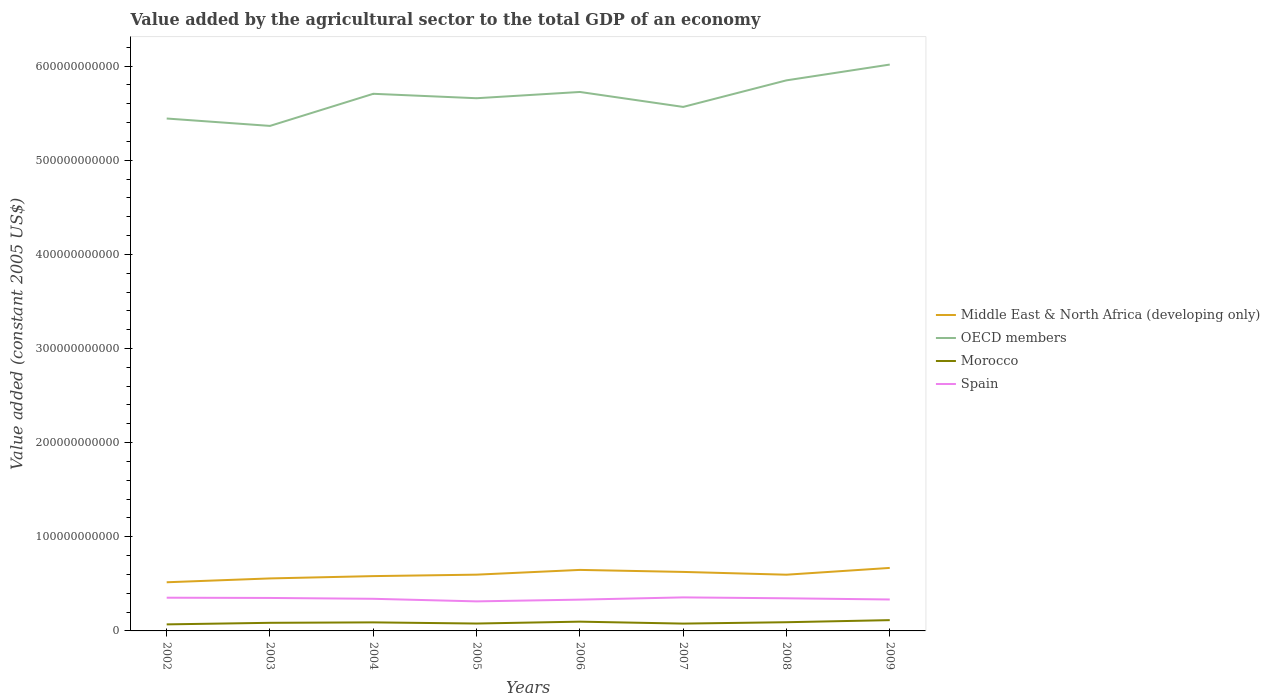How many different coloured lines are there?
Offer a very short reply. 4. Does the line corresponding to Middle East & North Africa (developing only) intersect with the line corresponding to Spain?
Provide a short and direct response. No. Is the number of lines equal to the number of legend labels?
Provide a succinct answer. Yes. Across all years, what is the maximum value added by the agricultural sector in Middle East & North Africa (developing only)?
Your answer should be very brief. 5.17e+1. In which year was the value added by the agricultural sector in Morocco maximum?
Give a very brief answer. 2002. What is the total value added by the agricultural sector in Middle East & North Africa (developing only) in the graph?
Your response must be concise. -1.55e+09. What is the difference between the highest and the second highest value added by the agricultural sector in OECD members?
Your answer should be very brief. 6.52e+1. What is the difference between the highest and the lowest value added by the agricultural sector in Middle East & North Africa (developing only)?
Offer a terse response. 3. Is the value added by the agricultural sector in Spain strictly greater than the value added by the agricultural sector in OECD members over the years?
Your response must be concise. Yes. What is the difference between two consecutive major ticks on the Y-axis?
Keep it short and to the point. 1.00e+11. Does the graph contain grids?
Ensure brevity in your answer.  No. What is the title of the graph?
Make the answer very short. Value added by the agricultural sector to the total GDP of an economy. What is the label or title of the Y-axis?
Provide a short and direct response. Value added (constant 2005 US$). What is the Value added (constant 2005 US$) of Middle East & North Africa (developing only) in 2002?
Keep it short and to the point. 5.17e+1. What is the Value added (constant 2005 US$) of OECD members in 2002?
Provide a short and direct response. 5.44e+11. What is the Value added (constant 2005 US$) of Morocco in 2002?
Your response must be concise. 6.95e+09. What is the Value added (constant 2005 US$) of Spain in 2002?
Provide a succinct answer. 3.53e+1. What is the Value added (constant 2005 US$) in Middle East & North Africa (developing only) in 2003?
Offer a very short reply. 5.58e+1. What is the Value added (constant 2005 US$) in OECD members in 2003?
Give a very brief answer. 5.36e+11. What is the Value added (constant 2005 US$) in Morocco in 2003?
Your answer should be compact. 8.62e+09. What is the Value added (constant 2005 US$) of Spain in 2003?
Offer a very short reply. 3.50e+1. What is the Value added (constant 2005 US$) of Middle East & North Africa (developing only) in 2004?
Your answer should be very brief. 5.82e+1. What is the Value added (constant 2005 US$) of OECD members in 2004?
Provide a succinct answer. 5.71e+11. What is the Value added (constant 2005 US$) in Morocco in 2004?
Make the answer very short. 9.07e+09. What is the Value added (constant 2005 US$) in Spain in 2004?
Offer a very short reply. 3.41e+1. What is the Value added (constant 2005 US$) of Middle East & North Africa (developing only) in 2005?
Ensure brevity in your answer.  5.98e+1. What is the Value added (constant 2005 US$) in OECD members in 2005?
Give a very brief answer. 5.66e+11. What is the Value added (constant 2005 US$) in Morocco in 2005?
Your answer should be very brief. 7.85e+09. What is the Value added (constant 2005 US$) of Spain in 2005?
Make the answer very short. 3.14e+1. What is the Value added (constant 2005 US$) of Middle East & North Africa (developing only) in 2006?
Provide a short and direct response. 6.48e+1. What is the Value added (constant 2005 US$) in OECD members in 2006?
Make the answer very short. 5.72e+11. What is the Value added (constant 2005 US$) in Morocco in 2006?
Provide a short and direct response. 9.83e+09. What is the Value added (constant 2005 US$) of Spain in 2006?
Keep it short and to the point. 3.32e+1. What is the Value added (constant 2005 US$) of Middle East & North Africa (developing only) in 2007?
Provide a short and direct response. 6.27e+1. What is the Value added (constant 2005 US$) in OECD members in 2007?
Your response must be concise. 5.57e+11. What is the Value added (constant 2005 US$) in Morocco in 2007?
Your response must be concise. 7.79e+09. What is the Value added (constant 2005 US$) of Spain in 2007?
Offer a terse response. 3.56e+1. What is the Value added (constant 2005 US$) of Middle East & North Africa (developing only) in 2008?
Provide a succinct answer. 5.97e+1. What is the Value added (constant 2005 US$) in OECD members in 2008?
Provide a succinct answer. 5.85e+11. What is the Value added (constant 2005 US$) of Morocco in 2008?
Your response must be concise. 9.24e+09. What is the Value added (constant 2005 US$) in Spain in 2008?
Offer a terse response. 3.47e+1. What is the Value added (constant 2005 US$) of Middle East & North Africa (developing only) in 2009?
Make the answer very short. 6.69e+1. What is the Value added (constant 2005 US$) of OECD members in 2009?
Offer a terse response. 6.02e+11. What is the Value added (constant 2005 US$) in Morocco in 2009?
Provide a succinct answer. 1.15e+1. What is the Value added (constant 2005 US$) of Spain in 2009?
Your answer should be very brief. 3.34e+1. Across all years, what is the maximum Value added (constant 2005 US$) in Middle East & North Africa (developing only)?
Offer a terse response. 6.69e+1. Across all years, what is the maximum Value added (constant 2005 US$) of OECD members?
Keep it short and to the point. 6.02e+11. Across all years, what is the maximum Value added (constant 2005 US$) of Morocco?
Offer a very short reply. 1.15e+1. Across all years, what is the maximum Value added (constant 2005 US$) in Spain?
Provide a short and direct response. 3.56e+1. Across all years, what is the minimum Value added (constant 2005 US$) in Middle East & North Africa (developing only)?
Give a very brief answer. 5.17e+1. Across all years, what is the minimum Value added (constant 2005 US$) in OECD members?
Make the answer very short. 5.36e+11. Across all years, what is the minimum Value added (constant 2005 US$) in Morocco?
Offer a very short reply. 6.95e+09. Across all years, what is the minimum Value added (constant 2005 US$) in Spain?
Your answer should be very brief. 3.14e+1. What is the total Value added (constant 2005 US$) in Middle East & North Africa (developing only) in the graph?
Keep it short and to the point. 4.80e+11. What is the total Value added (constant 2005 US$) in OECD members in the graph?
Offer a terse response. 4.53e+12. What is the total Value added (constant 2005 US$) of Morocco in the graph?
Your answer should be compact. 7.08e+1. What is the total Value added (constant 2005 US$) of Spain in the graph?
Give a very brief answer. 2.73e+11. What is the difference between the Value added (constant 2005 US$) in Middle East & North Africa (developing only) in 2002 and that in 2003?
Give a very brief answer. -4.07e+09. What is the difference between the Value added (constant 2005 US$) in OECD members in 2002 and that in 2003?
Ensure brevity in your answer.  7.85e+09. What is the difference between the Value added (constant 2005 US$) of Morocco in 2002 and that in 2003?
Offer a very short reply. -1.67e+09. What is the difference between the Value added (constant 2005 US$) of Spain in 2002 and that in 2003?
Offer a very short reply. 2.76e+08. What is the difference between the Value added (constant 2005 US$) of Middle East & North Africa (developing only) in 2002 and that in 2004?
Keep it short and to the point. -6.53e+09. What is the difference between the Value added (constant 2005 US$) of OECD members in 2002 and that in 2004?
Ensure brevity in your answer.  -2.63e+1. What is the difference between the Value added (constant 2005 US$) in Morocco in 2002 and that in 2004?
Your response must be concise. -2.12e+09. What is the difference between the Value added (constant 2005 US$) of Spain in 2002 and that in 2004?
Make the answer very short. 1.16e+09. What is the difference between the Value added (constant 2005 US$) of Middle East & North Africa (developing only) in 2002 and that in 2005?
Ensure brevity in your answer.  -8.07e+09. What is the difference between the Value added (constant 2005 US$) in OECD members in 2002 and that in 2005?
Ensure brevity in your answer.  -2.15e+1. What is the difference between the Value added (constant 2005 US$) of Morocco in 2002 and that in 2005?
Your response must be concise. -9.00e+08. What is the difference between the Value added (constant 2005 US$) of Spain in 2002 and that in 2005?
Ensure brevity in your answer.  3.90e+09. What is the difference between the Value added (constant 2005 US$) in Middle East & North Africa (developing only) in 2002 and that in 2006?
Offer a terse response. -1.31e+1. What is the difference between the Value added (constant 2005 US$) of OECD members in 2002 and that in 2006?
Offer a very short reply. -2.82e+1. What is the difference between the Value added (constant 2005 US$) of Morocco in 2002 and that in 2006?
Your response must be concise. -2.89e+09. What is the difference between the Value added (constant 2005 US$) in Spain in 2002 and that in 2006?
Make the answer very short. 2.04e+09. What is the difference between the Value added (constant 2005 US$) of Middle East & North Africa (developing only) in 2002 and that in 2007?
Keep it short and to the point. -1.10e+1. What is the difference between the Value added (constant 2005 US$) in OECD members in 2002 and that in 2007?
Your answer should be very brief. -1.23e+1. What is the difference between the Value added (constant 2005 US$) of Morocco in 2002 and that in 2007?
Offer a terse response. -8.42e+08. What is the difference between the Value added (constant 2005 US$) in Spain in 2002 and that in 2007?
Your answer should be very brief. -3.35e+08. What is the difference between the Value added (constant 2005 US$) of Middle East & North Africa (developing only) in 2002 and that in 2008?
Your answer should be compact. -8.03e+09. What is the difference between the Value added (constant 2005 US$) in OECD members in 2002 and that in 2008?
Keep it short and to the point. -4.05e+1. What is the difference between the Value added (constant 2005 US$) of Morocco in 2002 and that in 2008?
Keep it short and to the point. -2.29e+09. What is the difference between the Value added (constant 2005 US$) in Spain in 2002 and that in 2008?
Make the answer very short. 6.31e+08. What is the difference between the Value added (constant 2005 US$) in Middle East & North Africa (developing only) in 2002 and that in 2009?
Provide a succinct answer. -1.52e+1. What is the difference between the Value added (constant 2005 US$) in OECD members in 2002 and that in 2009?
Your response must be concise. -5.73e+1. What is the difference between the Value added (constant 2005 US$) of Morocco in 2002 and that in 2009?
Offer a terse response. -4.51e+09. What is the difference between the Value added (constant 2005 US$) of Spain in 2002 and that in 2009?
Ensure brevity in your answer.  1.89e+09. What is the difference between the Value added (constant 2005 US$) in Middle East & North Africa (developing only) in 2003 and that in 2004?
Offer a very short reply. -2.45e+09. What is the difference between the Value added (constant 2005 US$) in OECD members in 2003 and that in 2004?
Keep it short and to the point. -3.41e+1. What is the difference between the Value added (constant 2005 US$) of Morocco in 2003 and that in 2004?
Your answer should be very brief. -4.49e+08. What is the difference between the Value added (constant 2005 US$) of Spain in 2003 and that in 2004?
Keep it short and to the point. 8.86e+08. What is the difference between the Value added (constant 2005 US$) in Middle East & North Africa (developing only) in 2003 and that in 2005?
Ensure brevity in your answer.  -4.00e+09. What is the difference between the Value added (constant 2005 US$) of OECD members in 2003 and that in 2005?
Ensure brevity in your answer.  -2.94e+1. What is the difference between the Value added (constant 2005 US$) of Morocco in 2003 and that in 2005?
Provide a short and direct response. 7.74e+08. What is the difference between the Value added (constant 2005 US$) in Spain in 2003 and that in 2005?
Your answer should be compact. 3.63e+09. What is the difference between the Value added (constant 2005 US$) of Middle East & North Africa (developing only) in 2003 and that in 2006?
Provide a succinct answer. -9.05e+09. What is the difference between the Value added (constant 2005 US$) in OECD members in 2003 and that in 2006?
Keep it short and to the point. -3.61e+1. What is the difference between the Value added (constant 2005 US$) of Morocco in 2003 and that in 2006?
Provide a short and direct response. -1.21e+09. What is the difference between the Value added (constant 2005 US$) in Spain in 2003 and that in 2006?
Provide a succinct answer. 1.77e+09. What is the difference between the Value added (constant 2005 US$) in Middle East & North Africa (developing only) in 2003 and that in 2007?
Your answer should be compact. -6.91e+09. What is the difference between the Value added (constant 2005 US$) in OECD members in 2003 and that in 2007?
Your answer should be compact. -2.02e+1. What is the difference between the Value added (constant 2005 US$) in Morocco in 2003 and that in 2007?
Provide a succinct answer. 8.32e+08. What is the difference between the Value added (constant 2005 US$) in Spain in 2003 and that in 2007?
Your response must be concise. -6.11e+08. What is the difference between the Value added (constant 2005 US$) of Middle East & North Africa (developing only) in 2003 and that in 2008?
Provide a short and direct response. -3.95e+09. What is the difference between the Value added (constant 2005 US$) in OECD members in 2003 and that in 2008?
Provide a succinct answer. -4.84e+1. What is the difference between the Value added (constant 2005 US$) of Morocco in 2003 and that in 2008?
Make the answer very short. -6.19e+08. What is the difference between the Value added (constant 2005 US$) of Spain in 2003 and that in 2008?
Provide a succinct answer. 3.55e+08. What is the difference between the Value added (constant 2005 US$) in Middle East & North Africa (developing only) in 2003 and that in 2009?
Provide a short and direct response. -1.12e+1. What is the difference between the Value added (constant 2005 US$) in OECD members in 2003 and that in 2009?
Offer a terse response. -6.52e+1. What is the difference between the Value added (constant 2005 US$) in Morocco in 2003 and that in 2009?
Make the answer very short. -2.83e+09. What is the difference between the Value added (constant 2005 US$) of Spain in 2003 and that in 2009?
Provide a short and direct response. 1.61e+09. What is the difference between the Value added (constant 2005 US$) in Middle East & North Africa (developing only) in 2004 and that in 2005?
Your answer should be compact. -1.55e+09. What is the difference between the Value added (constant 2005 US$) in OECD members in 2004 and that in 2005?
Provide a short and direct response. 4.70e+09. What is the difference between the Value added (constant 2005 US$) in Morocco in 2004 and that in 2005?
Give a very brief answer. 1.22e+09. What is the difference between the Value added (constant 2005 US$) of Spain in 2004 and that in 2005?
Give a very brief answer. 2.74e+09. What is the difference between the Value added (constant 2005 US$) in Middle East & North Africa (developing only) in 2004 and that in 2006?
Your answer should be very brief. -6.59e+09. What is the difference between the Value added (constant 2005 US$) of OECD members in 2004 and that in 2006?
Offer a very short reply. -1.95e+09. What is the difference between the Value added (constant 2005 US$) in Morocco in 2004 and that in 2006?
Make the answer very short. -7.64e+08. What is the difference between the Value added (constant 2005 US$) of Spain in 2004 and that in 2006?
Keep it short and to the point. 8.82e+08. What is the difference between the Value added (constant 2005 US$) of Middle East & North Africa (developing only) in 2004 and that in 2007?
Give a very brief answer. -4.46e+09. What is the difference between the Value added (constant 2005 US$) in OECD members in 2004 and that in 2007?
Provide a succinct answer. 1.39e+1. What is the difference between the Value added (constant 2005 US$) of Morocco in 2004 and that in 2007?
Your answer should be very brief. 1.28e+09. What is the difference between the Value added (constant 2005 US$) in Spain in 2004 and that in 2007?
Provide a short and direct response. -1.50e+09. What is the difference between the Value added (constant 2005 US$) in Middle East & North Africa (developing only) in 2004 and that in 2008?
Ensure brevity in your answer.  -1.50e+09. What is the difference between the Value added (constant 2005 US$) of OECD members in 2004 and that in 2008?
Give a very brief answer. -1.43e+1. What is the difference between the Value added (constant 2005 US$) of Morocco in 2004 and that in 2008?
Offer a terse response. -1.69e+08. What is the difference between the Value added (constant 2005 US$) of Spain in 2004 and that in 2008?
Your answer should be compact. -5.31e+08. What is the difference between the Value added (constant 2005 US$) in Middle East & North Africa (developing only) in 2004 and that in 2009?
Provide a succinct answer. -8.71e+09. What is the difference between the Value added (constant 2005 US$) in OECD members in 2004 and that in 2009?
Your answer should be very brief. -3.11e+1. What is the difference between the Value added (constant 2005 US$) of Morocco in 2004 and that in 2009?
Keep it short and to the point. -2.38e+09. What is the difference between the Value added (constant 2005 US$) of Spain in 2004 and that in 2009?
Your answer should be very brief. 7.28e+08. What is the difference between the Value added (constant 2005 US$) in Middle East & North Africa (developing only) in 2005 and that in 2006?
Provide a short and direct response. -5.05e+09. What is the difference between the Value added (constant 2005 US$) in OECD members in 2005 and that in 2006?
Offer a very short reply. -6.65e+09. What is the difference between the Value added (constant 2005 US$) of Morocco in 2005 and that in 2006?
Ensure brevity in your answer.  -1.99e+09. What is the difference between the Value added (constant 2005 US$) in Spain in 2005 and that in 2006?
Keep it short and to the point. -1.86e+09. What is the difference between the Value added (constant 2005 US$) of Middle East & North Africa (developing only) in 2005 and that in 2007?
Ensure brevity in your answer.  -2.91e+09. What is the difference between the Value added (constant 2005 US$) of OECD members in 2005 and that in 2007?
Your response must be concise. 9.23e+09. What is the difference between the Value added (constant 2005 US$) of Morocco in 2005 and that in 2007?
Ensure brevity in your answer.  5.80e+07. What is the difference between the Value added (constant 2005 US$) in Spain in 2005 and that in 2007?
Provide a short and direct response. -4.24e+09. What is the difference between the Value added (constant 2005 US$) of Middle East & North Africa (developing only) in 2005 and that in 2008?
Offer a terse response. 4.66e+07. What is the difference between the Value added (constant 2005 US$) in OECD members in 2005 and that in 2008?
Your answer should be compact. -1.90e+1. What is the difference between the Value added (constant 2005 US$) in Morocco in 2005 and that in 2008?
Ensure brevity in your answer.  -1.39e+09. What is the difference between the Value added (constant 2005 US$) in Spain in 2005 and that in 2008?
Provide a short and direct response. -3.27e+09. What is the difference between the Value added (constant 2005 US$) in Middle East & North Africa (developing only) in 2005 and that in 2009?
Give a very brief answer. -7.17e+09. What is the difference between the Value added (constant 2005 US$) in OECD members in 2005 and that in 2009?
Your response must be concise. -3.58e+1. What is the difference between the Value added (constant 2005 US$) in Morocco in 2005 and that in 2009?
Offer a very short reply. -3.60e+09. What is the difference between the Value added (constant 2005 US$) of Spain in 2005 and that in 2009?
Offer a very short reply. -2.01e+09. What is the difference between the Value added (constant 2005 US$) of Middle East & North Africa (developing only) in 2006 and that in 2007?
Your answer should be very brief. 2.13e+09. What is the difference between the Value added (constant 2005 US$) of OECD members in 2006 and that in 2007?
Offer a terse response. 1.59e+1. What is the difference between the Value added (constant 2005 US$) in Morocco in 2006 and that in 2007?
Provide a short and direct response. 2.04e+09. What is the difference between the Value added (constant 2005 US$) of Spain in 2006 and that in 2007?
Your response must be concise. -2.38e+09. What is the difference between the Value added (constant 2005 US$) of Middle East & North Africa (developing only) in 2006 and that in 2008?
Your answer should be compact. 5.09e+09. What is the difference between the Value added (constant 2005 US$) of OECD members in 2006 and that in 2008?
Ensure brevity in your answer.  -1.23e+1. What is the difference between the Value added (constant 2005 US$) of Morocco in 2006 and that in 2008?
Ensure brevity in your answer.  5.94e+08. What is the difference between the Value added (constant 2005 US$) of Spain in 2006 and that in 2008?
Ensure brevity in your answer.  -1.41e+09. What is the difference between the Value added (constant 2005 US$) in Middle East & North Africa (developing only) in 2006 and that in 2009?
Your answer should be very brief. -2.12e+09. What is the difference between the Value added (constant 2005 US$) of OECD members in 2006 and that in 2009?
Keep it short and to the point. -2.91e+1. What is the difference between the Value added (constant 2005 US$) in Morocco in 2006 and that in 2009?
Ensure brevity in your answer.  -1.62e+09. What is the difference between the Value added (constant 2005 US$) of Spain in 2006 and that in 2009?
Your response must be concise. -1.54e+08. What is the difference between the Value added (constant 2005 US$) in Middle East & North Africa (developing only) in 2007 and that in 2008?
Offer a terse response. 2.96e+09. What is the difference between the Value added (constant 2005 US$) in OECD members in 2007 and that in 2008?
Your answer should be very brief. -2.82e+1. What is the difference between the Value added (constant 2005 US$) of Morocco in 2007 and that in 2008?
Give a very brief answer. -1.45e+09. What is the difference between the Value added (constant 2005 US$) in Spain in 2007 and that in 2008?
Give a very brief answer. 9.66e+08. What is the difference between the Value added (constant 2005 US$) of Middle East & North Africa (developing only) in 2007 and that in 2009?
Your answer should be very brief. -4.25e+09. What is the difference between the Value added (constant 2005 US$) of OECD members in 2007 and that in 2009?
Your answer should be compact. -4.50e+1. What is the difference between the Value added (constant 2005 US$) in Morocco in 2007 and that in 2009?
Provide a short and direct response. -3.66e+09. What is the difference between the Value added (constant 2005 US$) of Spain in 2007 and that in 2009?
Your answer should be very brief. 2.22e+09. What is the difference between the Value added (constant 2005 US$) of Middle East & North Africa (developing only) in 2008 and that in 2009?
Provide a succinct answer. -7.21e+09. What is the difference between the Value added (constant 2005 US$) in OECD members in 2008 and that in 2009?
Provide a succinct answer. -1.68e+1. What is the difference between the Value added (constant 2005 US$) of Morocco in 2008 and that in 2009?
Your answer should be very brief. -2.21e+09. What is the difference between the Value added (constant 2005 US$) of Spain in 2008 and that in 2009?
Make the answer very short. 1.26e+09. What is the difference between the Value added (constant 2005 US$) of Middle East & North Africa (developing only) in 2002 and the Value added (constant 2005 US$) of OECD members in 2003?
Offer a terse response. -4.85e+11. What is the difference between the Value added (constant 2005 US$) in Middle East & North Africa (developing only) in 2002 and the Value added (constant 2005 US$) in Morocco in 2003?
Your response must be concise. 4.31e+1. What is the difference between the Value added (constant 2005 US$) of Middle East & North Africa (developing only) in 2002 and the Value added (constant 2005 US$) of Spain in 2003?
Give a very brief answer. 1.67e+1. What is the difference between the Value added (constant 2005 US$) of OECD members in 2002 and the Value added (constant 2005 US$) of Morocco in 2003?
Keep it short and to the point. 5.36e+11. What is the difference between the Value added (constant 2005 US$) in OECD members in 2002 and the Value added (constant 2005 US$) in Spain in 2003?
Offer a terse response. 5.09e+11. What is the difference between the Value added (constant 2005 US$) in Morocco in 2002 and the Value added (constant 2005 US$) in Spain in 2003?
Provide a succinct answer. -2.81e+1. What is the difference between the Value added (constant 2005 US$) of Middle East & North Africa (developing only) in 2002 and the Value added (constant 2005 US$) of OECD members in 2004?
Offer a very short reply. -5.19e+11. What is the difference between the Value added (constant 2005 US$) in Middle East & North Africa (developing only) in 2002 and the Value added (constant 2005 US$) in Morocco in 2004?
Offer a very short reply. 4.26e+1. What is the difference between the Value added (constant 2005 US$) in Middle East & North Africa (developing only) in 2002 and the Value added (constant 2005 US$) in Spain in 2004?
Offer a very short reply. 1.76e+1. What is the difference between the Value added (constant 2005 US$) in OECD members in 2002 and the Value added (constant 2005 US$) in Morocco in 2004?
Ensure brevity in your answer.  5.35e+11. What is the difference between the Value added (constant 2005 US$) in OECD members in 2002 and the Value added (constant 2005 US$) in Spain in 2004?
Provide a succinct answer. 5.10e+11. What is the difference between the Value added (constant 2005 US$) of Morocco in 2002 and the Value added (constant 2005 US$) of Spain in 2004?
Your response must be concise. -2.72e+1. What is the difference between the Value added (constant 2005 US$) in Middle East & North Africa (developing only) in 2002 and the Value added (constant 2005 US$) in OECD members in 2005?
Give a very brief answer. -5.14e+11. What is the difference between the Value added (constant 2005 US$) of Middle East & North Africa (developing only) in 2002 and the Value added (constant 2005 US$) of Morocco in 2005?
Offer a terse response. 4.38e+1. What is the difference between the Value added (constant 2005 US$) in Middle East & North Africa (developing only) in 2002 and the Value added (constant 2005 US$) in Spain in 2005?
Make the answer very short. 2.03e+1. What is the difference between the Value added (constant 2005 US$) in OECD members in 2002 and the Value added (constant 2005 US$) in Morocco in 2005?
Your response must be concise. 5.36e+11. What is the difference between the Value added (constant 2005 US$) of OECD members in 2002 and the Value added (constant 2005 US$) of Spain in 2005?
Your answer should be compact. 5.13e+11. What is the difference between the Value added (constant 2005 US$) in Morocco in 2002 and the Value added (constant 2005 US$) in Spain in 2005?
Your answer should be compact. -2.44e+1. What is the difference between the Value added (constant 2005 US$) in Middle East & North Africa (developing only) in 2002 and the Value added (constant 2005 US$) in OECD members in 2006?
Keep it short and to the point. -5.21e+11. What is the difference between the Value added (constant 2005 US$) of Middle East & North Africa (developing only) in 2002 and the Value added (constant 2005 US$) of Morocco in 2006?
Offer a terse response. 4.19e+1. What is the difference between the Value added (constant 2005 US$) of Middle East & North Africa (developing only) in 2002 and the Value added (constant 2005 US$) of Spain in 2006?
Provide a succinct answer. 1.84e+1. What is the difference between the Value added (constant 2005 US$) in OECD members in 2002 and the Value added (constant 2005 US$) in Morocco in 2006?
Offer a terse response. 5.34e+11. What is the difference between the Value added (constant 2005 US$) of OECD members in 2002 and the Value added (constant 2005 US$) of Spain in 2006?
Your response must be concise. 5.11e+11. What is the difference between the Value added (constant 2005 US$) in Morocco in 2002 and the Value added (constant 2005 US$) in Spain in 2006?
Your response must be concise. -2.63e+1. What is the difference between the Value added (constant 2005 US$) in Middle East & North Africa (developing only) in 2002 and the Value added (constant 2005 US$) in OECD members in 2007?
Offer a terse response. -5.05e+11. What is the difference between the Value added (constant 2005 US$) in Middle East & North Africa (developing only) in 2002 and the Value added (constant 2005 US$) in Morocco in 2007?
Your answer should be very brief. 4.39e+1. What is the difference between the Value added (constant 2005 US$) of Middle East & North Africa (developing only) in 2002 and the Value added (constant 2005 US$) of Spain in 2007?
Offer a very short reply. 1.61e+1. What is the difference between the Value added (constant 2005 US$) in OECD members in 2002 and the Value added (constant 2005 US$) in Morocco in 2007?
Provide a short and direct response. 5.37e+11. What is the difference between the Value added (constant 2005 US$) in OECD members in 2002 and the Value added (constant 2005 US$) in Spain in 2007?
Provide a succinct answer. 5.09e+11. What is the difference between the Value added (constant 2005 US$) in Morocco in 2002 and the Value added (constant 2005 US$) in Spain in 2007?
Provide a short and direct response. -2.87e+1. What is the difference between the Value added (constant 2005 US$) in Middle East & North Africa (developing only) in 2002 and the Value added (constant 2005 US$) in OECD members in 2008?
Offer a terse response. -5.33e+11. What is the difference between the Value added (constant 2005 US$) in Middle East & North Africa (developing only) in 2002 and the Value added (constant 2005 US$) in Morocco in 2008?
Provide a short and direct response. 4.24e+1. What is the difference between the Value added (constant 2005 US$) in Middle East & North Africa (developing only) in 2002 and the Value added (constant 2005 US$) in Spain in 2008?
Keep it short and to the point. 1.70e+1. What is the difference between the Value added (constant 2005 US$) in OECD members in 2002 and the Value added (constant 2005 US$) in Morocco in 2008?
Offer a very short reply. 5.35e+11. What is the difference between the Value added (constant 2005 US$) in OECD members in 2002 and the Value added (constant 2005 US$) in Spain in 2008?
Provide a succinct answer. 5.10e+11. What is the difference between the Value added (constant 2005 US$) of Morocco in 2002 and the Value added (constant 2005 US$) of Spain in 2008?
Make the answer very short. -2.77e+1. What is the difference between the Value added (constant 2005 US$) of Middle East & North Africa (developing only) in 2002 and the Value added (constant 2005 US$) of OECD members in 2009?
Keep it short and to the point. -5.50e+11. What is the difference between the Value added (constant 2005 US$) in Middle East & North Africa (developing only) in 2002 and the Value added (constant 2005 US$) in Morocco in 2009?
Your answer should be very brief. 4.02e+1. What is the difference between the Value added (constant 2005 US$) of Middle East & North Africa (developing only) in 2002 and the Value added (constant 2005 US$) of Spain in 2009?
Make the answer very short. 1.83e+1. What is the difference between the Value added (constant 2005 US$) of OECD members in 2002 and the Value added (constant 2005 US$) of Morocco in 2009?
Give a very brief answer. 5.33e+11. What is the difference between the Value added (constant 2005 US$) of OECD members in 2002 and the Value added (constant 2005 US$) of Spain in 2009?
Offer a terse response. 5.11e+11. What is the difference between the Value added (constant 2005 US$) in Morocco in 2002 and the Value added (constant 2005 US$) in Spain in 2009?
Make the answer very short. -2.65e+1. What is the difference between the Value added (constant 2005 US$) in Middle East & North Africa (developing only) in 2003 and the Value added (constant 2005 US$) in OECD members in 2004?
Your answer should be very brief. -5.15e+11. What is the difference between the Value added (constant 2005 US$) in Middle East & North Africa (developing only) in 2003 and the Value added (constant 2005 US$) in Morocco in 2004?
Your response must be concise. 4.67e+1. What is the difference between the Value added (constant 2005 US$) of Middle East & North Africa (developing only) in 2003 and the Value added (constant 2005 US$) of Spain in 2004?
Provide a short and direct response. 2.16e+1. What is the difference between the Value added (constant 2005 US$) of OECD members in 2003 and the Value added (constant 2005 US$) of Morocco in 2004?
Offer a very short reply. 5.27e+11. What is the difference between the Value added (constant 2005 US$) in OECD members in 2003 and the Value added (constant 2005 US$) in Spain in 2004?
Your answer should be very brief. 5.02e+11. What is the difference between the Value added (constant 2005 US$) in Morocco in 2003 and the Value added (constant 2005 US$) in Spain in 2004?
Ensure brevity in your answer.  -2.55e+1. What is the difference between the Value added (constant 2005 US$) of Middle East & North Africa (developing only) in 2003 and the Value added (constant 2005 US$) of OECD members in 2005?
Offer a terse response. -5.10e+11. What is the difference between the Value added (constant 2005 US$) of Middle East & North Africa (developing only) in 2003 and the Value added (constant 2005 US$) of Morocco in 2005?
Make the answer very short. 4.79e+1. What is the difference between the Value added (constant 2005 US$) of Middle East & North Africa (developing only) in 2003 and the Value added (constant 2005 US$) of Spain in 2005?
Provide a succinct answer. 2.44e+1. What is the difference between the Value added (constant 2005 US$) of OECD members in 2003 and the Value added (constant 2005 US$) of Morocco in 2005?
Your answer should be compact. 5.29e+11. What is the difference between the Value added (constant 2005 US$) in OECD members in 2003 and the Value added (constant 2005 US$) in Spain in 2005?
Offer a terse response. 5.05e+11. What is the difference between the Value added (constant 2005 US$) in Morocco in 2003 and the Value added (constant 2005 US$) in Spain in 2005?
Keep it short and to the point. -2.28e+1. What is the difference between the Value added (constant 2005 US$) in Middle East & North Africa (developing only) in 2003 and the Value added (constant 2005 US$) in OECD members in 2006?
Ensure brevity in your answer.  -5.17e+11. What is the difference between the Value added (constant 2005 US$) of Middle East & North Africa (developing only) in 2003 and the Value added (constant 2005 US$) of Morocco in 2006?
Your response must be concise. 4.59e+1. What is the difference between the Value added (constant 2005 US$) in Middle East & North Africa (developing only) in 2003 and the Value added (constant 2005 US$) in Spain in 2006?
Keep it short and to the point. 2.25e+1. What is the difference between the Value added (constant 2005 US$) in OECD members in 2003 and the Value added (constant 2005 US$) in Morocco in 2006?
Provide a short and direct response. 5.27e+11. What is the difference between the Value added (constant 2005 US$) of OECD members in 2003 and the Value added (constant 2005 US$) of Spain in 2006?
Give a very brief answer. 5.03e+11. What is the difference between the Value added (constant 2005 US$) of Morocco in 2003 and the Value added (constant 2005 US$) of Spain in 2006?
Offer a very short reply. -2.46e+1. What is the difference between the Value added (constant 2005 US$) of Middle East & North Africa (developing only) in 2003 and the Value added (constant 2005 US$) of OECD members in 2007?
Give a very brief answer. -5.01e+11. What is the difference between the Value added (constant 2005 US$) of Middle East & North Africa (developing only) in 2003 and the Value added (constant 2005 US$) of Morocco in 2007?
Give a very brief answer. 4.80e+1. What is the difference between the Value added (constant 2005 US$) of Middle East & North Africa (developing only) in 2003 and the Value added (constant 2005 US$) of Spain in 2007?
Offer a terse response. 2.01e+1. What is the difference between the Value added (constant 2005 US$) of OECD members in 2003 and the Value added (constant 2005 US$) of Morocco in 2007?
Make the answer very short. 5.29e+11. What is the difference between the Value added (constant 2005 US$) in OECD members in 2003 and the Value added (constant 2005 US$) in Spain in 2007?
Provide a short and direct response. 5.01e+11. What is the difference between the Value added (constant 2005 US$) in Morocco in 2003 and the Value added (constant 2005 US$) in Spain in 2007?
Give a very brief answer. -2.70e+1. What is the difference between the Value added (constant 2005 US$) of Middle East & North Africa (developing only) in 2003 and the Value added (constant 2005 US$) of OECD members in 2008?
Offer a very short reply. -5.29e+11. What is the difference between the Value added (constant 2005 US$) of Middle East & North Africa (developing only) in 2003 and the Value added (constant 2005 US$) of Morocco in 2008?
Provide a short and direct response. 4.65e+1. What is the difference between the Value added (constant 2005 US$) in Middle East & North Africa (developing only) in 2003 and the Value added (constant 2005 US$) in Spain in 2008?
Provide a short and direct response. 2.11e+1. What is the difference between the Value added (constant 2005 US$) in OECD members in 2003 and the Value added (constant 2005 US$) in Morocco in 2008?
Your response must be concise. 5.27e+11. What is the difference between the Value added (constant 2005 US$) of OECD members in 2003 and the Value added (constant 2005 US$) of Spain in 2008?
Your response must be concise. 5.02e+11. What is the difference between the Value added (constant 2005 US$) of Morocco in 2003 and the Value added (constant 2005 US$) of Spain in 2008?
Provide a succinct answer. -2.60e+1. What is the difference between the Value added (constant 2005 US$) of Middle East & North Africa (developing only) in 2003 and the Value added (constant 2005 US$) of OECD members in 2009?
Give a very brief answer. -5.46e+11. What is the difference between the Value added (constant 2005 US$) in Middle East & North Africa (developing only) in 2003 and the Value added (constant 2005 US$) in Morocco in 2009?
Keep it short and to the point. 4.43e+1. What is the difference between the Value added (constant 2005 US$) of Middle East & North Africa (developing only) in 2003 and the Value added (constant 2005 US$) of Spain in 2009?
Keep it short and to the point. 2.24e+1. What is the difference between the Value added (constant 2005 US$) in OECD members in 2003 and the Value added (constant 2005 US$) in Morocco in 2009?
Keep it short and to the point. 5.25e+11. What is the difference between the Value added (constant 2005 US$) of OECD members in 2003 and the Value added (constant 2005 US$) of Spain in 2009?
Give a very brief answer. 5.03e+11. What is the difference between the Value added (constant 2005 US$) in Morocco in 2003 and the Value added (constant 2005 US$) in Spain in 2009?
Offer a terse response. -2.48e+1. What is the difference between the Value added (constant 2005 US$) of Middle East & North Africa (developing only) in 2004 and the Value added (constant 2005 US$) of OECD members in 2005?
Give a very brief answer. -5.08e+11. What is the difference between the Value added (constant 2005 US$) in Middle East & North Africa (developing only) in 2004 and the Value added (constant 2005 US$) in Morocco in 2005?
Offer a terse response. 5.04e+1. What is the difference between the Value added (constant 2005 US$) in Middle East & North Africa (developing only) in 2004 and the Value added (constant 2005 US$) in Spain in 2005?
Provide a short and direct response. 2.68e+1. What is the difference between the Value added (constant 2005 US$) in OECD members in 2004 and the Value added (constant 2005 US$) in Morocco in 2005?
Your response must be concise. 5.63e+11. What is the difference between the Value added (constant 2005 US$) of OECD members in 2004 and the Value added (constant 2005 US$) of Spain in 2005?
Offer a very short reply. 5.39e+11. What is the difference between the Value added (constant 2005 US$) of Morocco in 2004 and the Value added (constant 2005 US$) of Spain in 2005?
Provide a short and direct response. -2.23e+1. What is the difference between the Value added (constant 2005 US$) of Middle East & North Africa (developing only) in 2004 and the Value added (constant 2005 US$) of OECD members in 2006?
Give a very brief answer. -5.14e+11. What is the difference between the Value added (constant 2005 US$) of Middle East & North Africa (developing only) in 2004 and the Value added (constant 2005 US$) of Morocco in 2006?
Your response must be concise. 4.84e+1. What is the difference between the Value added (constant 2005 US$) of Middle East & North Africa (developing only) in 2004 and the Value added (constant 2005 US$) of Spain in 2006?
Your response must be concise. 2.50e+1. What is the difference between the Value added (constant 2005 US$) of OECD members in 2004 and the Value added (constant 2005 US$) of Morocco in 2006?
Make the answer very short. 5.61e+11. What is the difference between the Value added (constant 2005 US$) in OECD members in 2004 and the Value added (constant 2005 US$) in Spain in 2006?
Ensure brevity in your answer.  5.37e+11. What is the difference between the Value added (constant 2005 US$) of Morocco in 2004 and the Value added (constant 2005 US$) of Spain in 2006?
Ensure brevity in your answer.  -2.42e+1. What is the difference between the Value added (constant 2005 US$) in Middle East & North Africa (developing only) in 2004 and the Value added (constant 2005 US$) in OECD members in 2007?
Provide a short and direct response. -4.98e+11. What is the difference between the Value added (constant 2005 US$) of Middle East & North Africa (developing only) in 2004 and the Value added (constant 2005 US$) of Morocco in 2007?
Your answer should be compact. 5.04e+1. What is the difference between the Value added (constant 2005 US$) of Middle East & North Africa (developing only) in 2004 and the Value added (constant 2005 US$) of Spain in 2007?
Provide a short and direct response. 2.26e+1. What is the difference between the Value added (constant 2005 US$) in OECD members in 2004 and the Value added (constant 2005 US$) in Morocco in 2007?
Your answer should be compact. 5.63e+11. What is the difference between the Value added (constant 2005 US$) of OECD members in 2004 and the Value added (constant 2005 US$) of Spain in 2007?
Your answer should be compact. 5.35e+11. What is the difference between the Value added (constant 2005 US$) in Morocco in 2004 and the Value added (constant 2005 US$) in Spain in 2007?
Provide a short and direct response. -2.66e+1. What is the difference between the Value added (constant 2005 US$) of Middle East & North Africa (developing only) in 2004 and the Value added (constant 2005 US$) of OECD members in 2008?
Your response must be concise. -5.27e+11. What is the difference between the Value added (constant 2005 US$) in Middle East & North Africa (developing only) in 2004 and the Value added (constant 2005 US$) in Morocco in 2008?
Make the answer very short. 4.90e+1. What is the difference between the Value added (constant 2005 US$) of Middle East & North Africa (developing only) in 2004 and the Value added (constant 2005 US$) of Spain in 2008?
Provide a succinct answer. 2.36e+1. What is the difference between the Value added (constant 2005 US$) of OECD members in 2004 and the Value added (constant 2005 US$) of Morocco in 2008?
Provide a short and direct response. 5.61e+11. What is the difference between the Value added (constant 2005 US$) of OECD members in 2004 and the Value added (constant 2005 US$) of Spain in 2008?
Give a very brief answer. 5.36e+11. What is the difference between the Value added (constant 2005 US$) of Morocco in 2004 and the Value added (constant 2005 US$) of Spain in 2008?
Provide a short and direct response. -2.56e+1. What is the difference between the Value added (constant 2005 US$) in Middle East & North Africa (developing only) in 2004 and the Value added (constant 2005 US$) in OECD members in 2009?
Your response must be concise. -5.43e+11. What is the difference between the Value added (constant 2005 US$) in Middle East & North Africa (developing only) in 2004 and the Value added (constant 2005 US$) in Morocco in 2009?
Offer a very short reply. 4.68e+1. What is the difference between the Value added (constant 2005 US$) in Middle East & North Africa (developing only) in 2004 and the Value added (constant 2005 US$) in Spain in 2009?
Offer a terse response. 2.48e+1. What is the difference between the Value added (constant 2005 US$) in OECD members in 2004 and the Value added (constant 2005 US$) in Morocco in 2009?
Your answer should be compact. 5.59e+11. What is the difference between the Value added (constant 2005 US$) of OECD members in 2004 and the Value added (constant 2005 US$) of Spain in 2009?
Offer a very short reply. 5.37e+11. What is the difference between the Value added (constant 2005 US$) of Morocco in 2004 and the Value added (constant 2005 US$) of Spain in 2009?
Provide a succinct answer. -2.43e+1. What is the difference between the Value added (constant 2005 US$) of Middle East & North Africa (developing only) in 2005 and the Value added (constant 2005 US$) of OECD members in 2006?
Offer a very short reply. -5.13e+11. What is the difference between the Value added (constant 2005 US$) in Middle East & North Africa (developing only) in 2005 and the Value added (constant 2005 US$) in Morocco in 2006?
Ensure brevity in your answer.  4.99e+1. What is the difference between the Value added (constant 2005 US$) of Middle East & North Africa (developing only) in 2005 and the Value added (constant 2005 US$) of Spain in 2006?
Provide a succinct answer. 2.65e+1. What is the difference between the Value added (constant 2005 US$) of OECD members in 2005 and the Value added (constant 2005 US$) of Morocco in 2006?
Your response must be concise. 5.56e+11. What is the difference between the Value added (constant 2005 US$) of OECD members in 2005 and the Value added (constant 2005 US$) of Spain in 2006?
Ensure brevity in your answer.  5.33e+11. What is the difference between the Value added (constant 2005 US$) in Morocco in 2005 and the Value added (constant 2005 US$) in Spain in 2006?
Your answer should be compact. -2.54e+1. What is the difference between the Value added (constant 2005 US$) of Middle East & North Africa (developing only) in 2005 and the Value added (constant 2005 US$) of OECD members in 2007?
Give a very brief answer. -4.97e+11. What is the difference between the Value added (constant 2005 US$) in Middle East & North Africa (developing only) in 2005 and the Value added (constant 2005 US$) in Morocco in 2007?
Your answer should be compact. 5.20e+1. What is the difference between the Value added (constant 2005 US$) in Middle East & North Africa (developing only) in 2005 and the Value added (constant 2005 US$) in Spain in 2007?
Offer a terse response. 2.41e+1. What is the difference between the Value added (constant 2005 US$) of OECD members in 2005 and the Value added (constant 2005 US$) of Morocco in 2007?
Keep it short and to the point. 5.58e+11. What is the difference between the Value added (constant 2005 US$) of OECD members in 2005 and the Value added (constant 2005 US$) of Spain in 2007?
Provide a succinct answer. 5.30e+11. What is the difference between the Value added (constant 2005 US$) in Morocco in 2005 and the Value added (constant 2005 US$) in Spain in 2007?
Give a very brief answer. -2.78e+1. What is the difference between the Value added (constant 2005 US$) of Middle East & North Africa (developing only) in 2005 and the Value added (constant 2005 US$) of OECD members in 2008?
Give a very brief answer. -5.25e+11. What is the difference between the Value added (constant 2005 US$) in Middle East & North Africa (developing only) in 2005 and the Value added (constant 2005 US$) in Morocco in 2008?
Make the answer very short. 5.05e+1. What is the difference between the Value added (constant 2005 US$) of Middle East & North Africa (developing only) in 2005 and the Value added (constant 2005 US$) of Spain in 2008?
Offer a very short reply. 2.51e+1. What is the difference between the Value added (constant 2005 US$) of OECD members in 2005 and the Value added (constant 2005 US$) of Morocco in 2008?
Provide a succinct answer. 5.57e+11. What is the difference between the Value added (constant 2005 US$) of OECD members in 2005 and the Value added (constant 2005 US$) of Spain in 2008?
Offer a very short reply. 5.31e+11. What is the difference between the Value added (constant 2005 US$) in Morocco in 2005 and the Value added (constant 2005 US$) in Spain in 2008?
Provide a succinct answer. -2.68e+1. What is the difference between the Value added (constant 2005 US$) in Middle East & North Africa (developing only) in 2005 and the Value added (constant 2005 US$) in OECD members in 2009?
Your answer should be very brief. -5.42e+11. What is the difference between the Value added (constant 2005 US$) of Middle East & North Africa (developing only) in 2005 and the Value added (constant 2005 US$) of Morocco in 2009?
Provide a short and direct response. 4.83e+1. What is the difference between the Value added (constant 2005 US$) in Middle East & North Africa (developing only) in 2005 and the Value added (constant 2005 US$) in Spain in 2009?
Give a very brief answer. 2.64e+1. What is the difference between the Value added (constant 2005 US$) in OECD members in 2005 and the Value added (constant 2005 US$) in Morocco in 2009?
Keep it short and to the point. 5.54e+11. What is the difference between the Value added (constant 2005 US$) in OECD members in 2005 and the Value added (constant 2005 US$) in Spain in 2009?
Your response must be concise. 5.32e+11. What is the difference between the Value added (constant 2005 US$) of Morocco in 2005 and the Value added (constant 2005 US$) of Spain in 2009?
Your response must be concise. -2.56e+1. What is the difference between the Value added (constant 2005 US$) of Middle East & North Africa (developing only) in 2006 and the Value added (constant 2005 US$) of OECD members in 2007?
Give a very brief answer. -4.92e+11. What is the difference between the Value added (constant 2005 US$) of Middle East & North Africa (developing only) in 2006 and the Value added (constant 2005 US$) of Morocco in 2007?
Your answer should be very brief. 5.70e+1. What is the difference between the Value added (constant 2005 US$) in Middle East & North Africa (developing only) in 2006 and the Value added (constant 2005 US$) in Spain in 2007?
Your answer should be compact. 2.92e+1. What is the difference between the Value added (constant 2005 US$) of OECD members in 2006 and the Value added (constant 2005 US$) of Morocco in 2007?
Your answer should be very brief. 5.65e+11. What is the difference between the Value added (constant 2005 US$) in OECD members in 2006 and the Value added (constant 2005 US$) in Spain in 2007?
Your answer should be compact. 5.37e+11. What is the difference between the Value added (constant 2005 US$) in Morocco in 2006 and the Value added (constant 2005 US$) in Spain in 2007?
Provide a succinct answer. -2.58e+1. What is the difference between the Value added (constant 2005 US$) of Middle East & North Africa (developing only) in 2006 and the Value added (constant 2005 US$) of OECD members in 2008?
Ensure brevity in your answer.  -5.20e+11. What is the difference between the Value added (constant 2005 US$) in Middle East & North Africa (developing only) in 2006 and the Value added (constant 2005 US$) in Morocco in 2008?
Your answer should be very brief. 5.56e+1. What is the difference between the Value added (constant 2005 US$) in Middle East & North Africa (developing only) in 2006 and the Value added (constant 2005 US$) in Spain in 2008?
Offer a very short reply. 3.01e+1. What is the difference between the Value added (constant 2005 US$) in OECD members in 2006 and the Value added (constant 2005 US$) in Morocco in 2008?
Give a very brief answer. 5.63e+11. What is the difference between the Value added (constant 2005 US$) in OECD members in 2006 and the Value added (constant 2005 US$) in Spain in 2008?
Make the answer very short. 5.38e+11. What is the difference between the Value added (constant 2005 US$) in Morocco in 2006 and the Value added (constant 2005 US$) in Spain in 2008?
Give a very brief answer. -2.48e+1. What is the difference between the Value added (constant 2005 US$) in Middle East & North Africa (developing only) in 2006 and the Value added (constant 2005 US$) in OECD members in 2009?
Your response must be concise. -5.37e+11. What is the difference between the Value added (constant 2005 US$) of Middle East & North Africa (developing only) in 2006 and the Value added (constant 2005 US$) of Morocco in 2009?
Keep it short and to the point. 5.34e+1. What is the difference between the Value added (constant 2005 US$) in Middle East & North Africa (developing only) in 2006 and the Value added (constant 2005 US$) in Spain in 2009?
Your answer should be compact. 3.14e+1. What is the difference between the Value added (constant 2005 US$) in OECD members in 2006 and the Value added (constant 2005 US$) in Morocco in 2009?
Offer a very short reply. 5.61e+11. What is the difference between the Value added (constant 2005 US$) of OECD members in 2006 and the Value added (constant 2005 US$) of Spain in 2009?
Your answer should be very brief. 5.39e+11. What is the difference between the Value added (constant 2005 US$) of Morocco in 2006 and the Value added (constant 2005 US$) of Spain in 2009?
Keep it short and to the point. -2.36e+1. What is the difference between the Value added (constant 2005 US$) of Middle East & North Africa (developing only) in 2007 and the Value added (constant 2005 US$) of OECD members in 2008?
Give a very brief answer. -5.22e+11. What is the difference between the Value added (constant 2005 US$) in Middle East & North Africa (developing only) in 2007 and the Value added (constant 2005 US$) in Morocco in 2008?
Your response must be concise. 5.34e+1. What is the difference between the Value added (constant 2005 US$) of Middle East & North Africa (developing only) in 2007 and the Value added (constant 2005 US$) of Spain in 2008?
Offer a terse response. 2.80e+1. What is the difference between the Value added (constant 2005 US$) of OECD members in 2007 and the Value added (constant 2005 US$) of Morocco in 2008?
Keep it short and to the point. 5.47e+11. What is the difference between the Value added (constant 2005 US$) in OECD members in 2007 and the Value added (constant 2005 US$) in Spain in 2008?
Offer a terse response. 5.22e+11. What is the difference between the Value added (constant 2005 US$) in Morocco in 2007 and the Value added (constant 2005 US$) in Spain in 2008?
Offer a terse response. -2.69e+1. What is the difference between the Value added (constant 2005 US$) in Middle East & North Africa (developing only) in 2007 and the Value added (constant 2005 US$) in OECD members in 2009?
Keep it short and to the point. -5.39e+11. What is the difference between the Value added (constant 2005 US$) of Middle East & North Africa (developing only) in 2007 and the Value added (constant 2005 US$) of Morocco in 2009?
Provide a short and direct response. 5.12e+1. What is the difference between the Value added (constant 2005 US$) of Middle East & North Africa (developing only) in 2007 and the Value added (constant 2005 US$) of Spain in 2009?
Provide a succinct answer. 2.93e+1. What is the difference between the Value added (constant 2005 US$) in OECD members in 2007 and the Value added (constant 2005 US$) in Morocco in 2009?
Your answer should be very brief. 5.45e+11. What is the difference between the Value added (constant 2005 US$) in OECD members in 2007 and the Value added (constant 2005 US$) in Spain in 2009?
Make the answer very short. 5.23e+11. What is the difference between the Value added (constant 2005 US$) in Morocco in 2007 and the Value added (constant 2005 US$) in Spain in 2009?
Keep it short and to the point. -2.56e+1. What is the difference between the Value added (constant 2005 US$) of Middle East & North Africa (developing only) in 2008 and the Value added (constant 2005 US$) of OECD members in 2009?
Your answer should be compact. -5.42e+11. What is the difference between the Value added (constant 2005 US$) of Middle East & North Africa (developing only) in 2008 and the Value added (constant 2005 US$) of Morocco in 2009?
Keep it short and to the point. 4.83e+1. What is the difference between the Value added (constant 2005 US$) in Middle East & North Africa (developing only) in 2008 and the Value added (constant 2005 US$) in Spain in 2009?
Your answer should be very brief. 2.63e+1. What is the difference between the Value added (constant 2005 US$) of OECD members in 2008 and the Value added (constant 2005 US$) of Morocco in 2009?
Provide a succinct answer. 5.73e+11. What is the difference between the Value added (constant 2005 US$) in OECD members in 2008 and the Value added (constant 2005 US$) in Spain in 2009?
Make the answer very short. 5.51e+11. What is the difference between the Value added (constant 2005 US$) in Morocco in 2008 and the Value added (constant 2005 US$) in Spain in 2009?
Make the answer very short. -2.42e+1. What is the average Value added (constant 2005 US$) in Middle East & North Africa (developing only) per year?
Ensure brevity in your answer.  5.99e+1. What is the average Value added (constant 2005 US$) of OECD members per year?
Your answer should be compact. 5.67e+11. What is the average Value added (constant 2005 US$) of Morocco per year?
Your answer should be very brief. 8.85e+09. What is the average Value added (constant 2005 US$) of Spain per year?
Ensure brevity in your answer.  3.41e+1. In the year 2002, what is the difference between the Value added (constant 2005 US$) of Middle East & North Africa (developing only) and Value added (constant 2005 US$) of OECD members?
Your response must be concise. -4.93e+11. In the year 2002, what is the difference between the Value added (constant 2005 US$) in Middle East & North Africa (developing only) and Value added (constant 2005 US$) in Morocco?
Give a very brief answer. 4.47e+1. In the year 2002, what is the difference between the Value added (constant 2005 US$) in Middle East & North Africa (developing only) and Value added (constant 2005 US$) in Spain?
Keep it short and to the point. 1.64e+1. In the year 2002, what is the difference between the Value added (constant 2005 US$) in OECD members and Value added (constant 2005 US$) in Morocco?
Your answer should be compact. 5.37e+11. In the year 2002, what is the difference between the Value added (constant 2005 US$) of OECD members and Value added (constant 2005 US$) of Spain?
Your answer should be very brief. 5.09e+11. In the year 2002, what is the difference between the Value added (constant 2005 US$) of Morocco and Value added (constant 2005 US$) of Spain?
Keep it short and to the point. -2.83e+1. In the year 2003, what is the difference between the Value added (constant 2005 US$) in Middle East & North Africa (developing only) and Value added (constant 2005 US$) in OECD members?
Give a very brief answer. -4.81e+11. In the year 2003, what is the difference between the Value added (constant 2005 US$) in Middle East & North Africa (developing only) and Value added (constant 2005 US$) in Morocco?
Provide a succinct answer. 4.71e+1. In the year 2003, what is the difference between the Value added (constant 2005 US$) of Middle East & North Africa (developing only) and Value added (constant 2005 US$) of Spain?
Ensure brevity in your answer.  2.07e+1. In the year 2003, what is the difference between the Value added (constant 2005 US$) of OECD members and Value added (constant 2005 US$) of Morocco?
Your answer should be very brief. 5.28e+11. In the year 2003, what is the difference between the Value added (constant 2005 US$) in OECD members and Value added (constant 2005 US$) in Spain?
Offer a terse response. 5.01e+11. In the year 2003, what is the difference between the Value added (constant 2005 US$) in Morocco and Value added (constant 2005 US$) in Spain?
Your answer should be very brief. -2.64e+1. In the year 2004, what is the difference between the Value added (constant 2005 US$) of Middle East & North Africa (developing only) and Value added (constant 2005 US$) of OECD members?
Your answer should be very brief. -5.12e+11. In the year 2004, what is the difference between the Value added (constant 2005 US$) in Middle East & North Africa (developing only) and Value added (constant 2005 US$) in Morocco?
Offer a very short reply. 4.91e+1. In the year 2004, what is the difference between the Value added (constant 2005 US$) of Middle East & North Africa (developing only) and Value added (constant 2005 US$) of Spain?
Your answer should be very brief. 2.41e+1. In the year 2004, what is the difference between the Value added (constant 2005 US$) in OECD members and Value added (constant 2005 US$) in Morocco?
Your answer should be very brief. 5.61e+11. In the year 2004, what is the difference between the Value added (constant 2005 US$) in OECD members and Value added (constant 2005 US$) in Spain?
Your answer should be compact. 5.36e+11. In the year 2004, what is the difference between the Value added (constant 2005 US$) in Morocco and Value added (constant 2005 US$) in Spain?
Your answer should be compact. -2.51e+1. In the year 2005, what is the difference between the Value added (constant 2005 US$) of Middle East & North Africa (developing only) and Value added (constant 2005 US$) of OECD members?
Your response must be concise. -5.06e+11. In the year 2005, what is the difference between the Value added (constant 2005 US$) of Middle East & North Africa (developing only) and Value added (constant 2005 US$) of Morocco?
Make the answer very short. 5.19e+1. In the year 2005, what is the difference between the Value added (constant 2005 US$) of Middle East & North Africa (developing only) and Value added (constant 2005 US$) of Spain?
Keep it short and to the point. 2.84e+1. In the year 2005, what is the difference between the Value added (constant 2005 US$) in OECD members and Value added (constant 2005 US$) in Morocco?
Keep it short and to the point. 5.58e+11. In the year 2005, what is the difference between the Value added (constant 2005 US$) of OECD members and Value added (constant 2005 US$) of Spain?
Offer a very short reply. 5.34e+11. In the year 2005, what is the difference between the Value added (constant 2005 US$) of Morocco and Value added (constant 2005 US$) of Spain?
Your answer should be very brief. -2.35e+1. In the year 2006, what is the difference between the Value added (constant 2005 US$) of Middle East & North Africa (developing only) and Value added (constant 2005 US$) of OECD members?
Ensure brevity in your answer.  -5.08e+11. In the year 2006, what is the difference between the Value added (constant 2005 US$) in Middle East & North Africa (developing only) and Value added (constant 2005 US$) in Morocco?
Give a very brief answer. 5.50e+1. In the year 2006, what is the difference between the Value added (constant 2005 US$) of Middle East & North Africa (developing only) and Value added (constant 2005 US$) of Spain?
Provide a succinct answer. 3.16e+1. In the year 2006, what is the difference between the Value added (constant 2005 US$) of OECD members and Value added (constant 2005 US$) of Morocco?
Your answer should be very brief. 5.63e+11. In the year 2006, what is the difference between the Value added (constant 2005 US$) of OECD members and Value added (constant 2005 US$) of Spain?
Offer a very short reply. 5.39e+11. In the year 2006, what is the difference between the Value added (constant 2005 US$) in Morocco and Value added (constant 2005 US$) in Spain?
Your answer should be very brief. -2.34e+1. In the year 2007, what is the difference between the Value added (constant 2005 US$) of Middle East & North Africa (developing only) and Value added (constant 2005 US$) of OECD members?
Provide a succinct answer. -4.94e+11. In the year 2007, what is the difference between the Value added (constant 2005 US$) in Middle East & North Africa (developing only) and Value added (constant 2005 US$) in Morocco?
Provide a succinct answer. 5.49e+1. In the year 2007, what is the difference between the Value added (constant 2005 US$) of Middle East & North Africa (developing only) and Value added (constant 2005 US$) of Spain?
Give a very brief answer. 2.71e+1. In the year 2007, what is the difference between the Value added (constant 2005 US$) in OECD members and Value added (constant 2005 US$) in Morocco?
Make the answer very short. 5.49e+11. In the year 2007, what is the difference between the Value added (constant 2005 US$) of OECD members and Value added (constant 2005 US$) of Spain?
Offer a very short reply. 5.21e+11. In the year 2007, what is the difference between the Value added (constant 2005 US$) in Morocco and Value added (constant 2005 US$) in Spain?
Offer a terse response. -2.78e+1. In the year 2008, what is the difference between the Value added (constant 2005 US$) of Middle East & North Africa (developing only) and Value added (constant 2005 US$) of OECD members?
Make the answer very short. -5.25e+11. In the year 2008, what is the difference between the Value added (constant 2005 US$) in Middle East & North Africa (developing only) and Value added (constant 2005 US$) in Morocco?
Your response must be concise. 5.05e+1. In the year 2008, what is the difference between the Value added (constant 2005 US$) of Middle East & North Africa (developing only) and Value added (constant 2005 US$) of Spain?
Your answer should be compact. 2.51e+1. In the year 2008, what is the difference between the Value added (constant 2005 US$) of OECD members and Value added (constant 2005 US$) of Morocco?
Offer a terse response. 5.76e+11. In the year 2008, what is the difference between the Value added (constant 2005 US$) of OECD members and Value added (constant 2005 US$) of Spain?
Provide a succinct answer. 5.50e+11. In the year 2008, what is the difference between the Value added (constant 2005 US$) of Morocco and Value added (constant 2005 US$) of Spain?
Provide a succinct answer. -2.54e+1. In the year 2009, what is the difference between the Value added (constant 2005 US$) of Middle East & North Africa (developing only) and Value added (constant 2005 US$) of OECD members?
Ensure brevity in your answer.  -5.35e+11. In the year 2009, what is the difference between the Value added (constant 2005 US$) of Middle East & North Africa (developing only) and Value added (constant 2005 US$) of Morocco?
Make the answer very short. 5.55e+1. In the year 2009, what is the difference between the Value added (constant 2005 US$) in Middle East & North Africa (developing only) and Value added (constant 2005 US$) in Spain?
Your answer should be compact. 3.35e+1. In the year 2009, what is the difference between the Value added (constant 2005 US$) of OECD members and Value added (constant 2005 US$) of Morocco?
Offer a very short reply. 5.90e+11. In the year 2009, what is the difference between the Value added (constant 2005 US$) of OECD members and Value added (constant 2005 US$) of Spain?
Give a very brief answer. 5.68e+11. In the year 2009, what is the difference between the Value added (constant 2005 US$) in Morocco and Value added (constant 2005 US$) in Spain?
Your answer should be very brief. -2.19e+1. What is the ratio of the Value added (constant 2005 US$) of Middle East & North Africa (developing only) in 2002 to that in 2003?
Provide a short and direct response. 0.93. What is the ratio of the Value added (constant 2005 US$) in OECD members in 2002 to that in 2003?
Your response must be concise. 1.01. What is the ratio of the Value added (constant 2005 US$) of Morocco in 2002 to that in 2003?
Give a very brief answer. 0.81. What is the ratio of the Value added (constant 2005 US$) of Spain in 2002 to that in 2003?
Offer a terse response. 1.01. What is the ratio of the Value added (constant 2005 US$) of Middle East & North Africa (developing only) in 2002 to that in 2004?
Make the answer very short. 0.89. What is the ratio of the Value added (constant 2005 US$) of OECD members in 2002 to that in 2004?
Your response must be concise. 0.95. What is the ratio of the Value added (constant 2005 US$) in Morocco in 2002 to that in 2004?
Offer a terse response. 0.77. What is the ratio of the Value added (constant 2005 US$) in Spain in 2002 to that in 2004?
Offer a terse response. 1.03. What is the ratio of the Value added (constant 2005 US$) of Middle East & North Africa (developing only) in 2002 to that in 2005?
Give a very brief answer. 0.86. What is the ratio of the Value added (constant 2005 US$) in OECD members in 2002 to that in 2005?
Your answer should be compact. 0.96. What is the ratio of the Value added (constant 2005 US$) in Morocco in 2002 to that in 2005?
Make the answer very short. 0.89. What is the ratio of the Value added (constant 2005 US$) of Spain in 2002 to that in 2005?
Offer a terse response. 1.12. What is the ratio of the Value added (constant 2005 US$) in Middle East & North Africa (developing only) in 2002 to that in 2006?
Your response must be concise. 0.8. What is the ratio of the Value added (constant 2005 US$) of OECD members in 2002 to that in 2006?
Provide a short and direct response. 0.95. What is the ratio of the Value added (constant 2005 US$) in Morocco in 2002 to that in 2006?
Give a very brief answer. 0.71. What is the ratio of the Value added (constant 2005 US$) in Spain in 2002 to that in 2006?
Keep it short and to the point. 1.06. What is the ratio of the Value added (constant 2005 US$) of Middle East & North Africa (developing only) in 2002 to that in 2007?
Provide a short and direct response. 0.82. What is the ratio of the Value added (constant 2005 US$) in OECD members in 2002 to that in 2007?
Keep it short and to the point. 0.98. What is the ratio of the Value added (constant 2005 US$) in Morocco in 2002 to that in 2007?
Your answer should be compact. 0.89. What is the ratio of the Value added (constant 2005 US$) in Spain in 2002 to that in 2007?
Offer a very short reply. 0.99. What is the ratio of the Value added (constant 2005 US$) in Middle East & North Africa (developing only) in 2002 to that in 2008?
Your answer should be compact. 0.87. What is the ratio of the Value added (constant 2005 US$) of OECD members in 2002 to that in 2008?
Your answer should be very brief. 0.93. What is the ratio of the Value added (constant 2005 US$) of Morocco in 2002 to that in 2008?
Provide a succinct answer. 0.75. What is the ratio of the Value added (constant 2005 US$) in Spain in 2002 to that in 2008?
Ensure brevity in your answer.  1.02. What is the ratio of the Value added (constant 2005 US$) of Middle East & North Africa (developing only) in 2002 to that in 2009?
Your answer should be compact. 0.77. What is the ratio of the Value added (constant 2005 US$) of OECD members in 2002 to that in 2009?
Your response must be concise. 0.9. What is the ratio of the Value added (constant 2005 US$) of Morocco in 2002 to that in 2009?
Make the answer very short. 0.61. What is the ratio of the Value added (constant 2005 US$) of Spain in 2002 to that in 2009?
Your response must be concise. 1.06. What is the ratio of the Value added (constant 2005 US$) of Middle East & North Africa (developing only) in 2003 to that in 2004?
Offer a terse response. 0.96. What is the ratio of the Value added (constant 2005 US$) in OECD members in 2003 to that in 2004?
Offer a terse response. 0.94. What is the ratio of the Value added (constant 2005 US$) in Morocco in 2003 to that in 2004?
Offer a terse response. 0.95. What is the ratio of the Value added (constant 2005 US$) of Spain in 2003 to that in 2004?
Provide a succinct answer. 1.03. What is the ratio of the Value added (constant 2005 US$) in Middle East & North Africa (developing only) in 2003 to that in 2005?
Give a very brief answer. 0.93. What is the ratio of the Value added (constant 2005 US$) in OECD members in 2003 to that in 2005?
Your response must be concise. 0.95. What is the ratio of the Value added (constant 2005 US$) of Morocco in 2003 to that in 2005?
Your answer should be compact. 1.1. What is the ratio of the Value added (constant 2005 US$) of Spain in 2003 to that in 2005?
Ensure brevity in your answer.  1.12. What is the ratio of the Value added (constant 2005 US$) in Middle East & North Africa (developing only) in 2003 to that in 2006?
Ensure brevity in your answer.  0.86. What is the ratio of the Value added (constant 2005 US$) of OECD members in 2003 to that in 2006?
Provide a short and direct response. 0.94. What is the ratio of the Value added (constant 2005 US$) of Morocco in 2003 to that in 2006?
Your response must be concise. 0.88. What is the ratio of the Value added (constant 2005 US$) of Spain in 2003 to that in 2006?
Offer a very short reply. 1.05. What is the ratio of the Value added (constant 2005 US$) of Middle East & North Africa (developing only) in 2003 to that in 2007?
Give a very brief answer. 0.89. What is the ratio of the Value added (constant 2005 US$) in OECD members in 2003 to that in 2007?
Your answer should be compact. 0.96. What is the ratio of the Value added (constant 2005 US$) of Morocco in 2003 to that in 2007?
Ensure brevity in your answer.  1.11. What is the ratio of the Value added (constant 2005 US$) in Spain in 2003 to that in 2007?
Your response must be concise. 0.98. What is the ratio of the Value added (constant 2005 US$) of Middle East & North Africa (developing only) in 2003 to that in 2008?
Give a very brief answer. 0.93. What is the ratio of the Value added (constant 2005 US$) of OECD members in 2003 to that in 2008?
Ensure brevity in your answer.  0.92. What is the ratio of the Value added (constant 2005 US$) of Morocco in 2003 to that in 2008?
Provide a short and direct response. 0.93. What is the ratio of the Value added (constant 2005 US$) of Spain in 2003 to that in 2008?
Your response must be concise. 1.01. What is the ratio of the Value added (constant 2005 US$) in Middle East & North Africa (developing only) in 2003 to that in 2009?
Your response must be concise. 0.83. What is the ratio of the Value added (constant 2005 US$) in OECD members in 2003 to that in 2009?
Provide a short and direct response. 0.89. What is the ratio of the Value added (constant 2005 US$) of Morocco in 2003 to that in 2009?
Keep it short and to the point. 0.75. What is the ratio of the Value added (constant 2005 US$) in Spain in 2003 to that in 2009?
Offer a very short reply. 1.05. What is the ratio of the Value added (constant 2005 US$) in Middle East & North Africa (developing only) in 2004 to that in 2005?
Keep it short and to the point. 0.97. What is the ratio of the Value added (constant 2005 US$) in OECD members in 2004 to that in 2005?
Your response must be concise. 1.01. What is the ratio of the Value added (constant 2005 US$) of Morocco in 2004 to that in 2005?
Offer a very short reply. 1.16. What is the ratio of the Value added (constant 2005 US$) of Spain in 2004 to that in 2005?
Your answer should be very brief. 1.09. What is the ratio of the Value added (constant 2005 US$) in Middle East & North Africa (developing only) in 2004 to that in 2006?
Your answer should be compact. 0.9. What is the ratio of the Value added (constant 2005 US$) of Morocco in 2004 to that in 2006?
Your answer should be compact. 0.92. What is the ratio of the Value added (constant 2005 US$) of Spain in 2004 to that in 2006?
Offer a very short reply. 1.03. What is the ratio of the Value added (constant 2005 US$) of Middle East & North Africa (developing only) in 2004 to that in 2007?
Provide a short and direct response. 0.93. What is the ratio of the Value added (constant 2005 US$) of Morocco in 2004 to that in 2007?
Make the answer very short. 1.16. What is the ratio of the Value added (constant 2005 US$) in Spain in 2004 to that in 2007?
Offer a terse response. 0.96. What is the ratio of the Value added (constant 2005 US$) in Middle East & North Africa (developing only) in 2004 to that in 2008?
Offer a very short reply. 0.97. What is the ratio of the Value added (constant 2005 US$) of OECD members in 2004 to that in 2008?
Make the answer very short. 0.98. What is the ratio of the Value added (constant 2005 US$) of Morocco in 2004 to that in 2008?
Offer a very short reply. 0.98. What is the ratio of the Value added (constant 2005 US$) in Spain in 2004 to that in 2008?
Offer a terse response. 0.98. What is the ratio of the Value added (constant 2005 US$) of Middle East & North Africa (developing only) in 2004 to that in 2009?
Your answer should be compact. 0.87. What is the ratio of the Value added (constant 2005 US$) in OECD members in 2004 to that in 2009?
Give a very brief answer. 0.95. What is the ratio of the Value added (constant 2005 US$) in Morocco in 2004 to that in 2009?
Offer a terse response. 0.79. What is the ratio of the Value added (constant 2005 US$) in Spain in 2004 to that in 2009?
Make the answer very short. 1.02. What is the ratio of the Value added (constant 2005 US$) of Middle East & North Africa (developing only) in 2005 to that in 2006?
Make the answer very short. 0.92. What is the ratio of the Value added (constant 2005 US$) of OECD members in 2005 to that in 2006?
Keep it short and to the point. 0.99. What is the ratio of the Value added (constant 2005 US$) of Morocco in 2005 to that in 2006?
Offer a very short reply. 0.8. What is the ratio of the Value added (constant 2005 US$) of Spain in 2005 to that in 2006?
Offer a very short reply. 0.94. What is the ratio of the Value added (constant 2005 US$) in Middle East & North Africa (developing only) in 2005 to that in 2007?
Provide a short and direct response. 0.95. What is the ratio of the Value added (constant 2005 US$) of OECD members in 2005 to that in 2007?
Provide a short and direct response. 1.02. What is the ratio of the Value added (constant 2005 US$) in Morocco in 2005 to that in 2007?
Keep it short and to the point. 1.01. What is the ratio of the Value added (constant 2005 US$) in Spain in 2005 to that in 2007?
Your answer should be compact. 0.88. What is the ratio of the Value added (constant 2005 US$) in Middle East & North Africa (developing only) in 2005 to that in 2008?
Keep it short and to the point. 1. What is the ratio of the Value added (constant 2005 US$) of OECD members in 2005 to that in 2008?
Your answer should be very brief. 0.97. What is the ratio of the Value added (constant 2005 US$) of Morocco in 2005 to that in 2008?
Keep it short and to the point. 0.85. What is the ratio of the Value added (constant 2005 US$) of Spain in 2005 to that in 2008?
Give a very brief answer. 0.91. What is the ratio of the Value added (constant 2005 US$) of Middle East & North Africa (developing only) in 2005 to that in 2009?
Your response must be concise. 0.89. What is the ratio of the Value added (constant 2005 US$) of OECD members in 2005 to that in 2009?
Ensure brevity in your answer.  0.94. What is the ratio of the Value added (constant 2005 US$) in Morocco in 2005 to that in 2009?
Provide a succinct answer. 0.69. What is the ratio of the Value added (constant 2005 US$) of Spain in 2005 to that in 2009?
Ensure brevity in your answer.  0.94. What is the ratio of the Value added (constant 2005 US$) in Middle East & North Africa (developing only) in 2006 to that in 2007?
Offer a very short reply. 1.03. What is the ratio of the Value added (constant 2005 US$) of OECD members in 2006 to that in 2007?
Provide a succinct answer. 1.03. What is the ratio of the Value added (constant 2005 US$) in Morocco in 2006 to that in 2007?
Keep it short and to the point. 1.26. What is the ratio of the Value added (constant 2005 US$) of Spain in 2006 to that in 2007?
Keep it short and to the point. 0.93. What is the ratio of the Value added (constant 2005 US$) of Middle East & North Africa (developing only) in 2006 to that in 2008?
Provide a short and direct response. 1.09. What is the ratio of the Value added (constant 2005 US$) of OECD members in 2006 to that in 2008?
Your response must be concise. 0.98. What is the ratio of the Value added (constant 2005 US$) of Morocco in 2006 to that in 2008?
Your response must be concise. 1.06. What is the ratio of the Value added (constant 2005 US$) in Spain in 2006 to that in 2008?
Your answer should be very brief. 0.96. What is the ratio of the Value added (constant 2005 US$) in Middle East & North Africa (developing only) in 2006 to that in 2009?
Offer a very short reply. 0.97. What is the ratio of the Value added (constant 2005 US$) of OECD members in 2006 to that in 2009?
Ensure brevity in your answer.  0.95. What is the ratio of the Value added (constant 2005 US$) in Morocco in 2006 to that in 2009?
Ensure brevity in your answer.  0.86. What is the ratio of the Value added (constant 2005 US$) in Spain in 2006 to that in 2009?
Provide a short and direct response. 1. What is the ratio of the Value added (constant 2005 US$) in Middle East & North Africa (developing only) in 2007 to that in 2008?
Provide a short and direct response. 1.05. What is the ratio of the Value added (constant 2005 US$) in OECD members in 2007 to that in 2008?
Offer a terse response. 0.95. What is the ratio of the Value added (constant 2005 US$) in Morocco in 2007 to that in 2008?
Make the answer very short. 0.84. What is the ratio of the Value added (constant 2005 US$) of Spain in 2007 to that in 2008?
Offer a terse response. 1.03. What is the ratio of the Value added (constant 2005 US$) in Middle East & North Africa (developing only) in 2007 to that in 2009?
Your answer should be compact. 0.94. What is the ratio of the Value added (constant 2005 US$) of OECD members in 2007 to that in 2009?
Give a very brief answer. 0.93. What is the ratio of the Value added (constant 2005 US$) in Morocco in 2007 to that in 2009?
Keep it short and to the point. 0.68. What is the ratio of the Value added (constant 2005 US$) in Spain in 2007 to that in 2009?
Give a very brief answer. 1.07. What is the ratio of the Value added (constant 2005 US$) of Middle East & North Africa (developing only) in 2008 to that in 2009?
Your response must be concise. 0.89. What is the ratio of the Value added (constant 2005 US$) in OECD members in 2008 to that in 2009?
Your response must be concise. 0.97. What is the ratio of the Value added (constant 2005 US$) of Morocco in 2008 to that in 2009?
Offer a terse response. 0.81. What is the ratio of the Value added (constant 2005 US$) of Spain in 2008 to that in 2009?
Offer a terse response. 1.04. What is the difference between the highest and the second highest Value added (constant 2005 US$) of Middle East & North Africa (developing only)?
Your response must be concise. 2.12e+09. What is the difference between the highest and the second highest Value added (constant 2005 US$) in OECD members?
Ensure brevity in your answer.  1.68e+1. What is the difference between the highest and the second highest Value added (constant 2005 US$) of Morocco?
Your answer should be compact. 1.62e+09. What is the difference between the highest and the second highest Value added (constant 2005 US$) of Spain?
Offer a very short reply. 3.35e+08. What is the difference between the highest and the lowest Value added (constant 2005 US$) in Middle East & North Africa (developing only)?
Provide a short and direct response. 1.52e+1. What is the difference between the highest and the lowest Value added (constant 2005 US$) of OECD members?
Offer a very short reply. 6.52e+1. What is the difference between the highest and the lowest Value added (constant 2005 US$) of Morocco?
Give a very brief answer. 4.51e+09. What is the difference between the highest and the lowest Value added (constant 2005 US$) of Spain?
Offer a very short reply. 4.24e+09. 